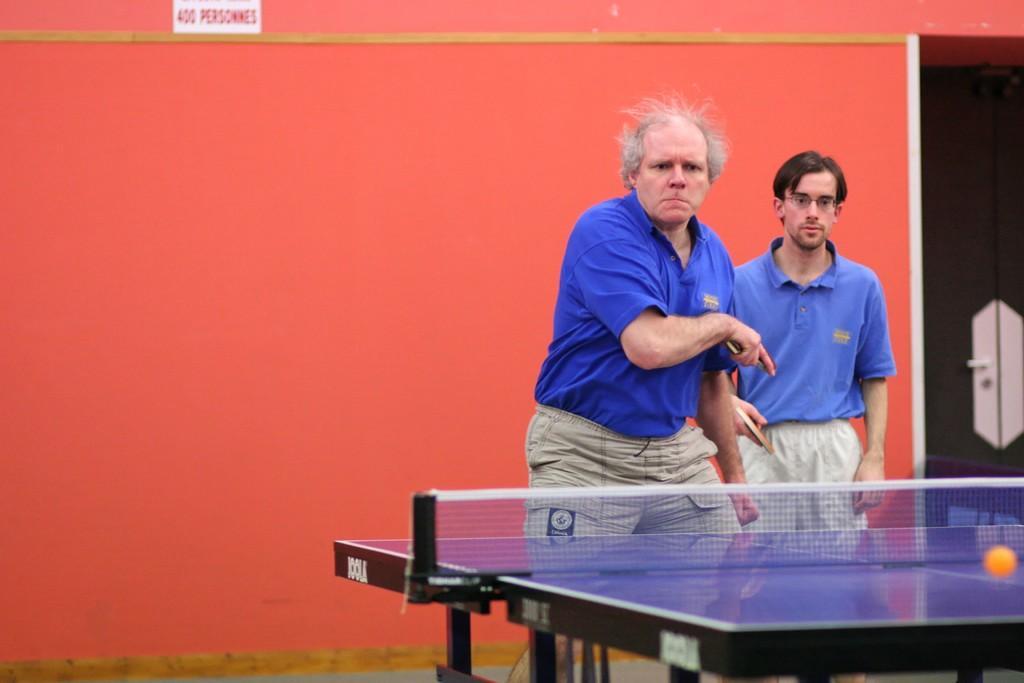In one or two sentences, can you explain what this image depicts? In the background we can see the wall, door. At the top portion of the picture we can see a board. In this picture we can see the men holding rackets and they are playing table tennis. On the right side of the picture we can see a table, net and a ball. 